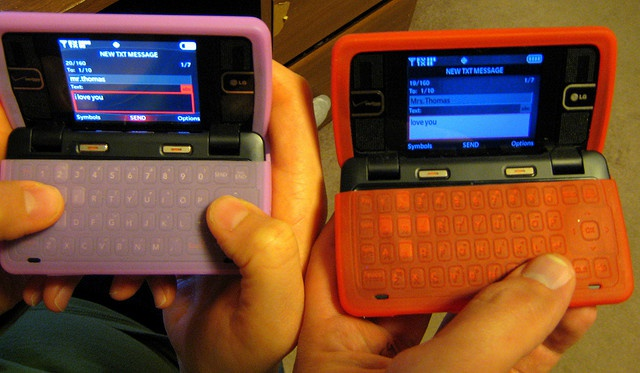Describe the objects in this image and their specific colors. I can see cell phone in maroon, black, red, and brown tones, cell phone in maroon, black, gray, tan, and brown tones, people in maroon, orange, black, and brown tones, and people in maroon, red, and orange tones in this image. 